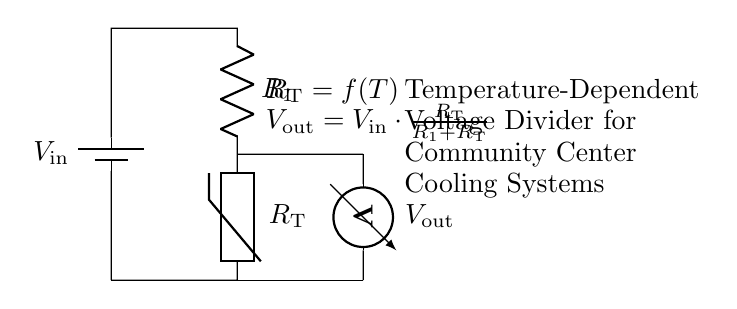What is the input voltage of the circuit? The input voltage is labeled as V_in, typically indicated in the circuit diagram. As no specific numerical value is given in the code, we infer it from the diagram.
Answer: V_in What are the components used in this circuit? The components in this circuit include a battery (V_in), a resistor (R_1), and a thermistor (R_T). These are the main elements identified in the circuit diagram.
Answer: Battery, Resistor, Thermistor What is the output voltage formula shown in the circuit? The output voltage, V_out, is given by the formula: V_out equals V_in multiplied by R_T divided by the sum of R_1 and R_T. This is explicitly stated in the diagram.
Answer: V_out = V_in * (R_T / (R_1 + R_T)) What happens to the output voltage when the temperature increases? As the temperature increases, the resistance of the thermistor (R_T) typically decreases. According to the voltage divider principle, a decrease in R_T will lower V_out, since it is effectively being divided by a smaller number.
Answer: V_out decreases Which component varies with temperature in this circuit? The component that changes with temperature is the thermistor, as denoted by R_T, which is explicitly stated as being a function of temperature (f(T)).
Answer: Thermistor What is the purpose of this circuit in community centers? The purpose of this circuit is to monitor and regulate the cooling systems in community centers by utilizing temperature readings to adjust operation based on the output voltage.
Answer: Monitor cooling systems What does the term 'Voltage Divider' signify in this circuit? The term 'Voltage Divider' refers to the configuration that splits the input voltage into smaller parts, creating an output voltage that depends on the resistance values in the circuit. This is the fundamental principle being utilized here.
Answer: Voltage splitting configuration 